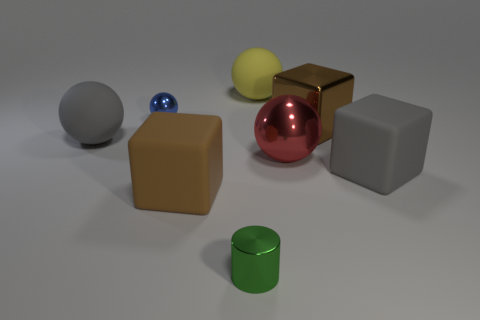What is the thing that is behind the gray matte ball and in front of the tiny sphere made of?
Provide a succinct answer. Metal. There is a rubber ball in front of the blue metallic ball; does it have the same size as the large metallic cube?
Your answer should be very brief. Yes. What is the gray cube made of?
Make the answer very short. Rubber. There is a block on the left side of the green cylinder; what is its color?
Ensure brevity in your answer.  Brown. How many tiny things are either yellow things or green metallic cylinders?
Your answer should be very brief. 1. Do the large object that is in front of the gray cube and the large matte object behind the blue object have the same color?
Provide a succinct answer. No. How many other objects are there of the same color as the metal block?
Ensure brevity in your answer.  1. How many red things are either tiny balls or big metallic balls?
Provide a short and direct response. 1. There is a blue metal object; is it the same shape as the thing that is in front of the large brown matte object?
Give a very brief answer. No. There is a tiny green object; what shape is it?
Your answer should be very brief. Cylinder. 